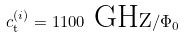<formula> <loc_0><loc_0><loc_500><loc_500>c _ { \text {t} } ^ { ( i ) } = 1 1 0 0 \text { GHz} / \Phi _ { 0 }</formula> 